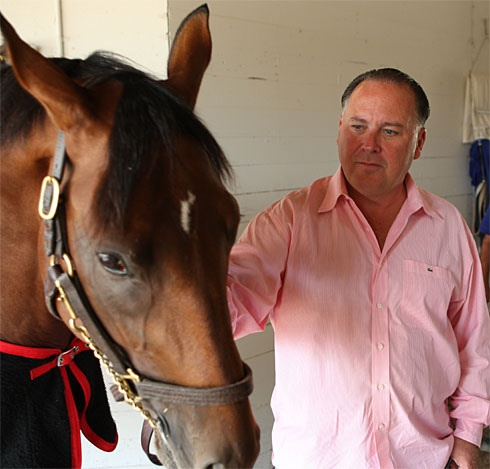Describe the objects in this image and their specific colors. I can see horse in beige, black, gray, maroon, and brown tones and people in beige, brown, lightpink, and lavender tones in this image. 